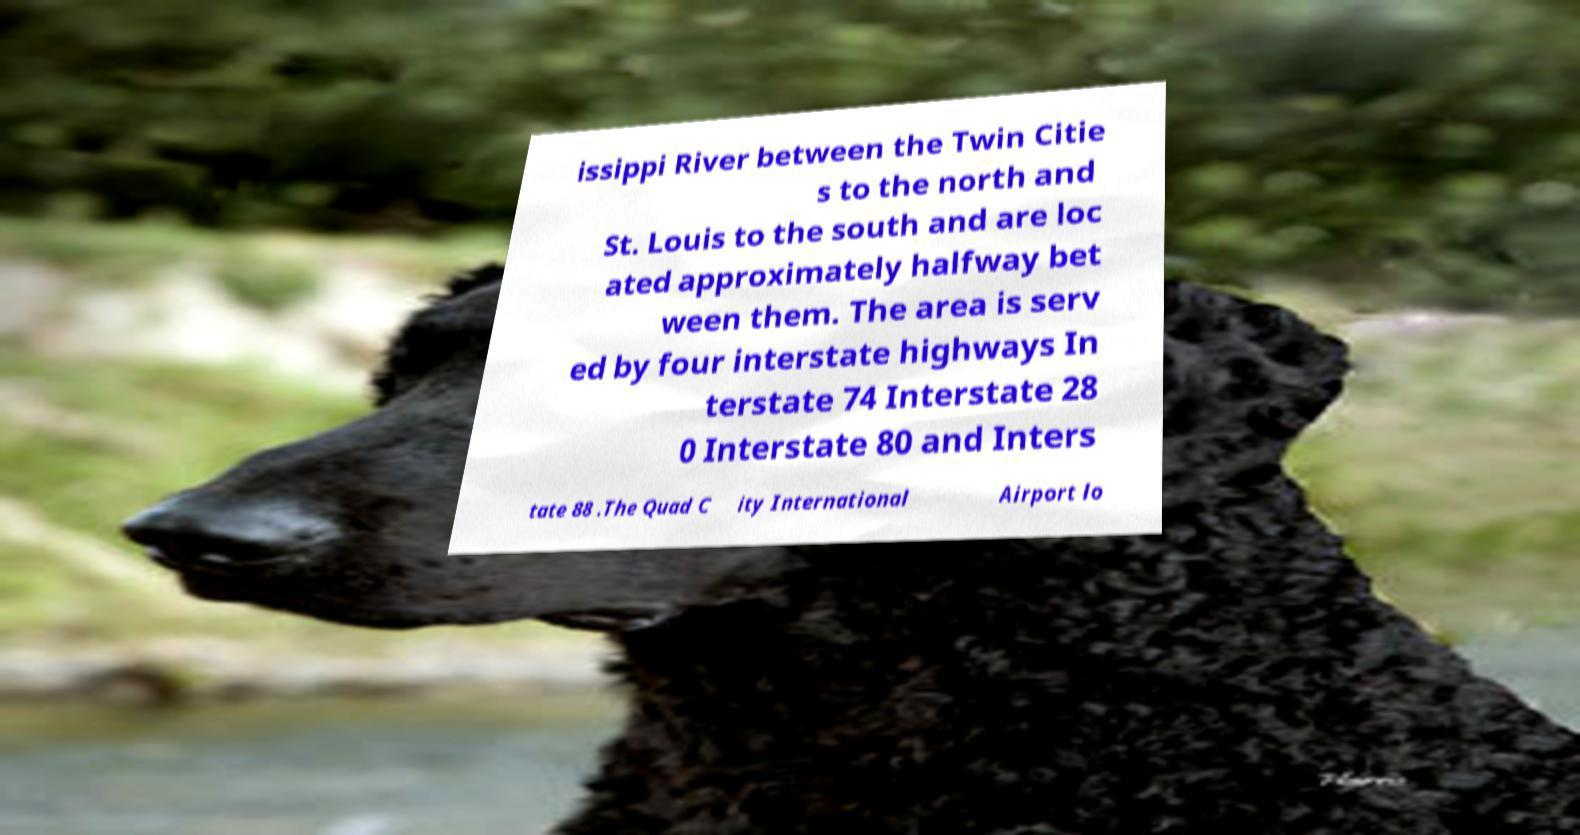Could you extract and type out the text from this image? issippi River between the Twin Citie s to the north and St. Louis to the south and are loc ated approximately halfway bet ween them. The area is serv ed by four interstate highways In terstate 74 Interstate 28 0 Interstate 80 and Inters tate 88 .The Quad C ity International Airport lo 